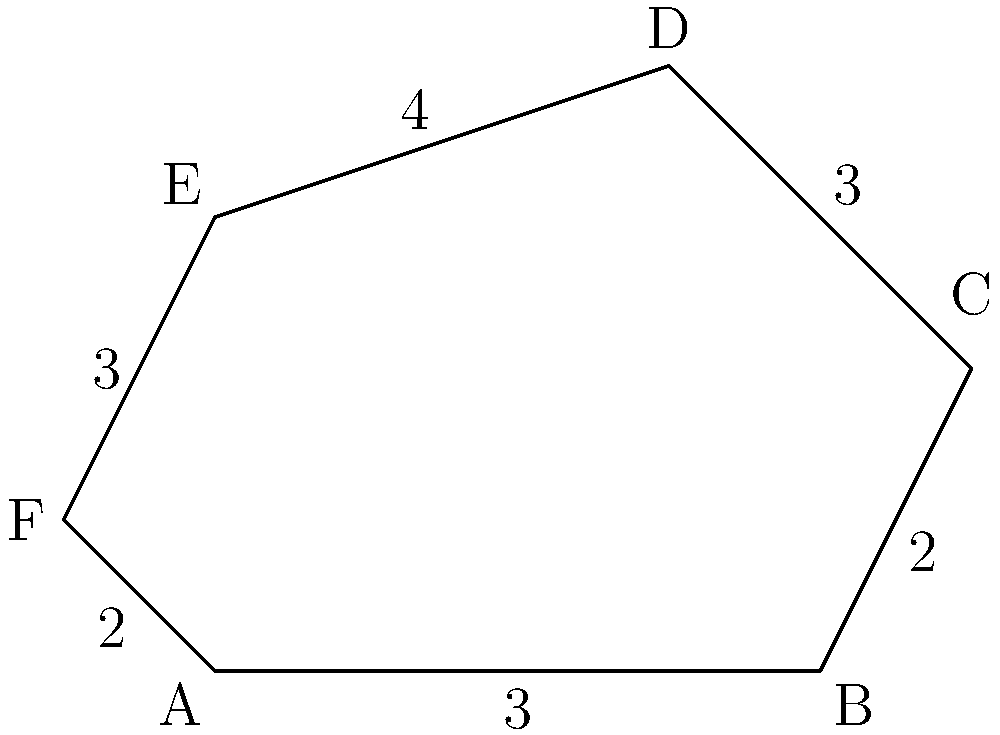Calculate the perimeter of the irregular hexagon ABCDEF given the following side lengths: AB = 3 units, BC = 2 units, CD = 3 units, DE = 4 units, EF = 3 units, and FA = 2 units. To calculate the perimeter of an irregular hexagon, we need to sum up the lengths of all its sides. Here's the step-by-step process:

1. Identify the given side lengths:
   AB = 3 units
   BC = 2 units
   CD = 3 units
   DE = 4 units
   EF = 3 units
   FA = 2 units

2. Add all the side lengths:
   Perimeter = AB + BC + CD + DE + EF + FA
   Perimeter = 3 + 2 + 3 + 4 + 3 + 2

3. Perform the addition:
   Perimeter = 17 units

Therefore, the perimeter of the irregular hexagon ABCDEF is 17 units.
Answer: 17 units 